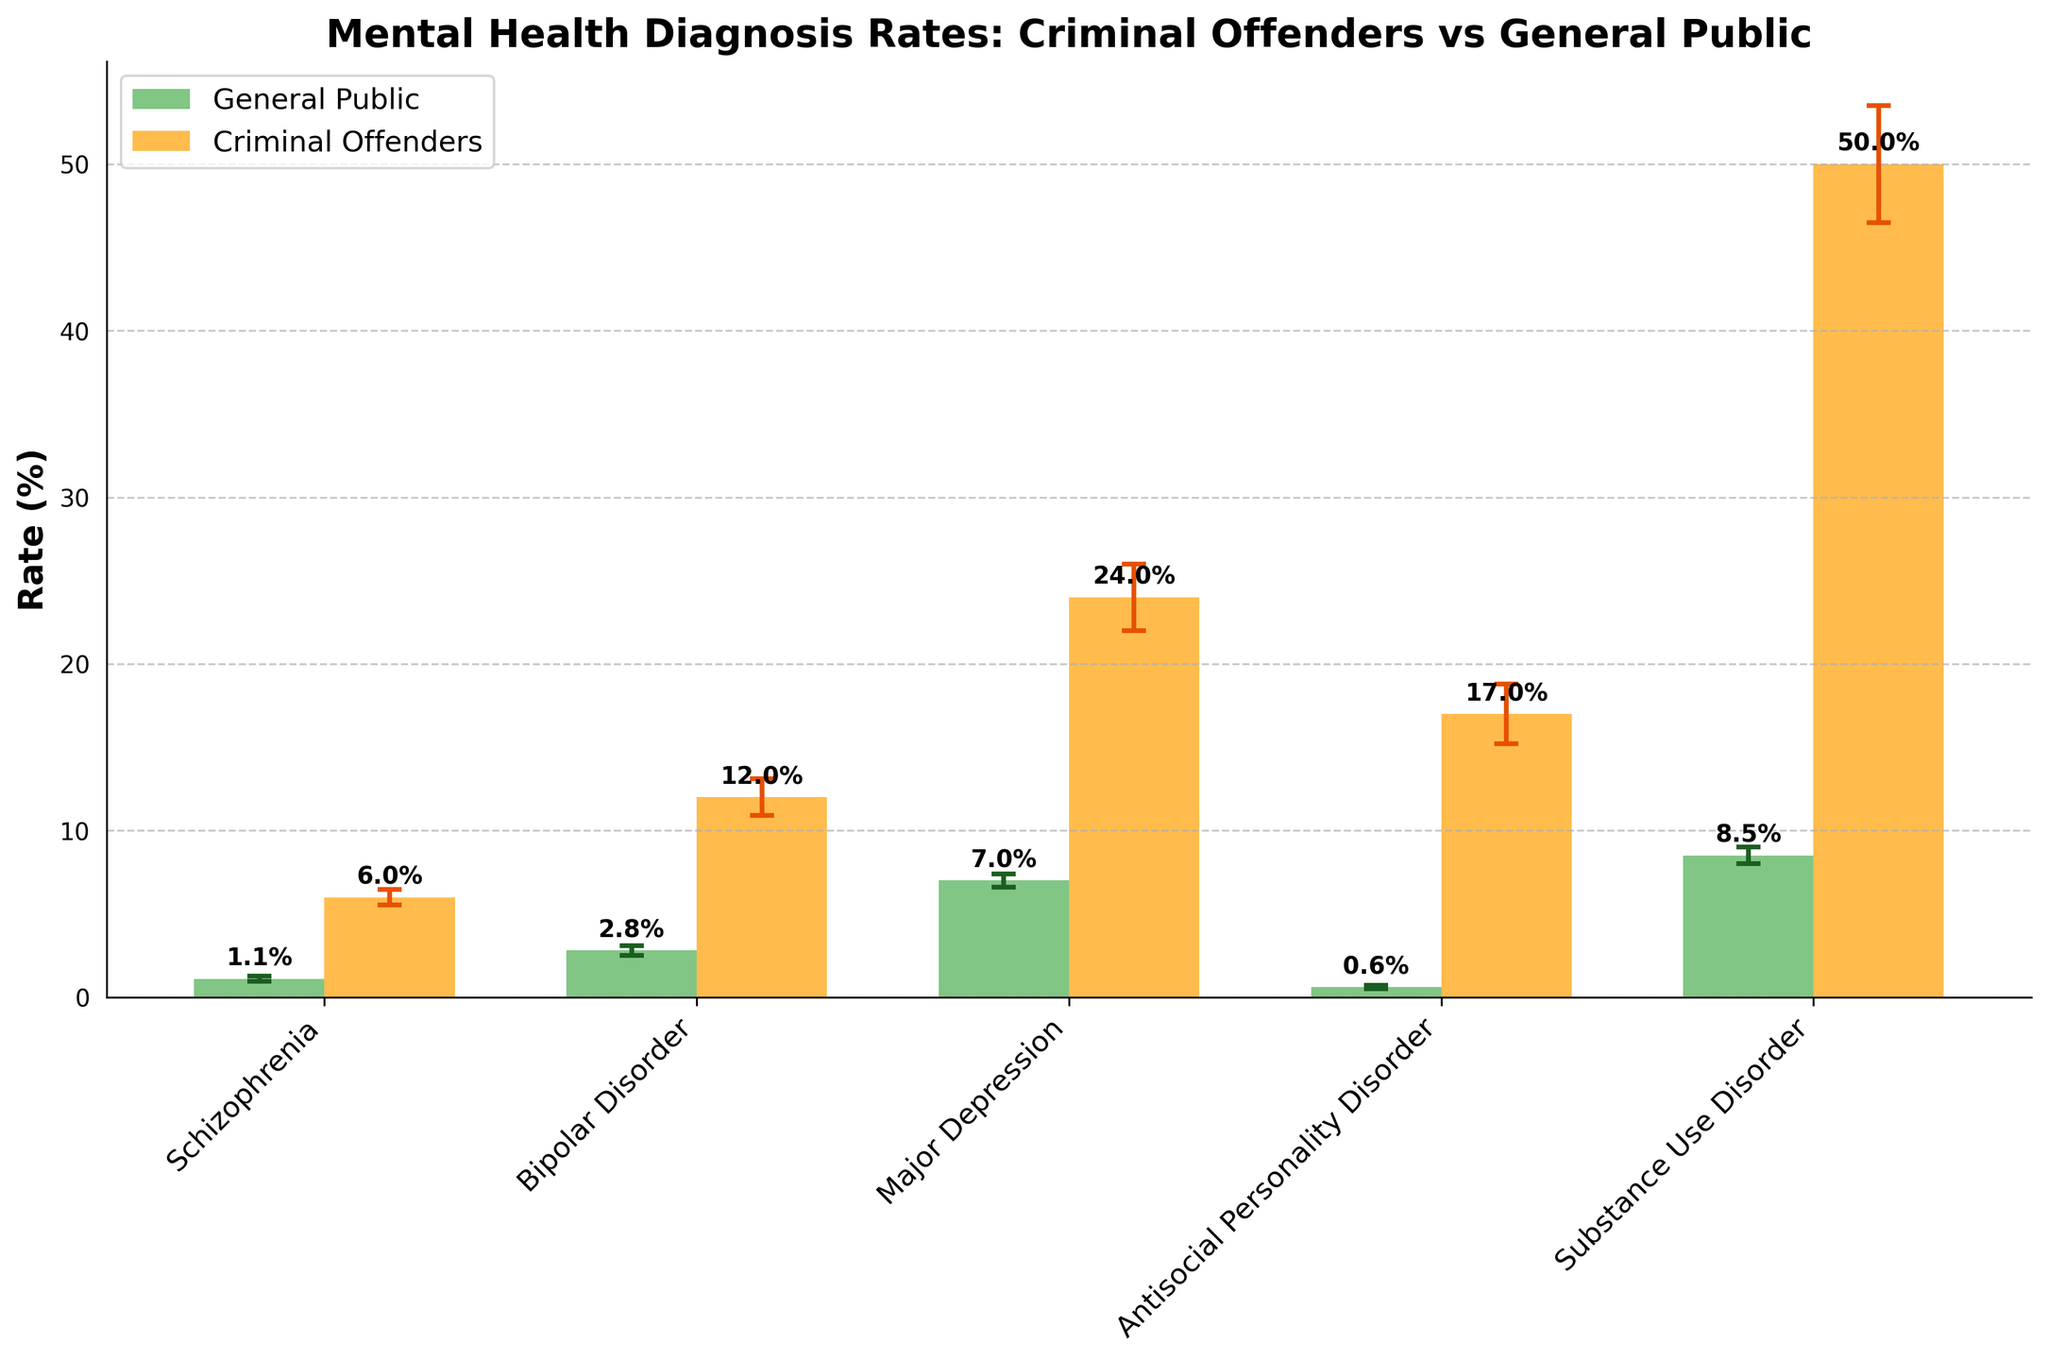How many types of disorders are shown in the figure? Count the number of distinct disorder labels on the x-axis.
Answer: 5 Which population has a higher rate of Schizophrenia? Look at the bars corresponding to Schizophrenia and compare their heights for 'General Public' vs 'Criminal Offenders'.
Answer: Criminal Offenders What is the rate of Major Depression in the general public? Find the bar labeled 'Major Depression' and check its height for the 'General Public'.
Answer: 7% How do the rates of Antisocial Personality Disorder compare between the general public and criminal offenders? Compare the heights of the bars for 'Antisocial Personality Disorder' between the two populations.
Answer: Higher in Criminal Offenders What is the error margin for Substance Use Disorder in criminal offenders? Look for the error bar height for 'Substance Use Disorder' in the 'Criminal Offenders' bar.
Answer: 3.5% What is the difference in the rate of Bipolar Disorder between criminal offenders and the general public? Subtract the rate of Bipolar Disorder in the general public from that in criminal offenders.
Answer: 9.2% Which disorder has the greatest variance between the populations? Compare the differences between bar heights for each disorder between the 'General Public' and 'Criminal Offenders'.
Answer: Substance Use Disorder What is the average rate of mental health disorders in the general public? Sum up the rates of all disorders in the general public and divide by the number of disorders. (1.1 + 2.8 + 7 + 0.6 + 8.5) / 5
Answer: 4% Which population has a lower rate of Schizophrenia but a higher rate of Substance Use Disorder? Compare and identify the population with lower Schizophrenia and higher Substance Use Disorder rates.
Answer: Criminal Offenders What is the total sum of rates for all disorders in criminal offenders? Sum the rates of all disorders specifically for criminal offenders. (6 + 12 + 24 + 17 + 50)
Answer: 109% 